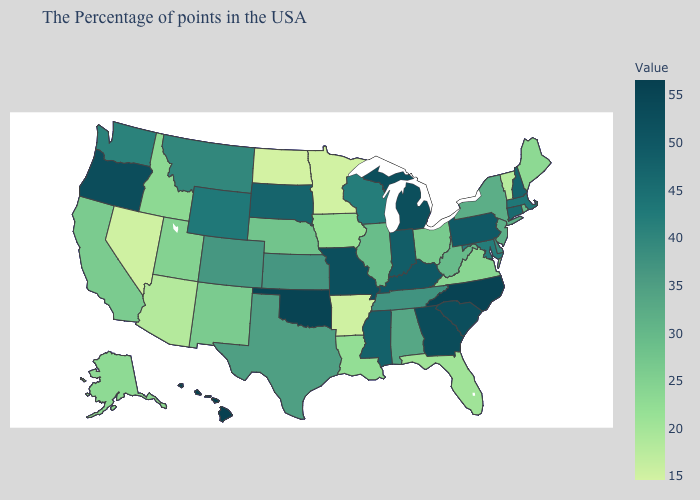Is the legend a continuous bar?
Write a very short answer. Yes. Is the legend a continuous bar?
Be succinct. Yes. Which states have the lowest value in the MidWest?
Keep it brief. North Dakota. Among the states that border Virginia , does West Virginia have the lowest value?
Answer briefly. Yes. Among the states that border North Carolina , does Virginia have the highest value?
Short answer required. No. Which states hav the highest value in the West?
Be succinct. Hawaii. 